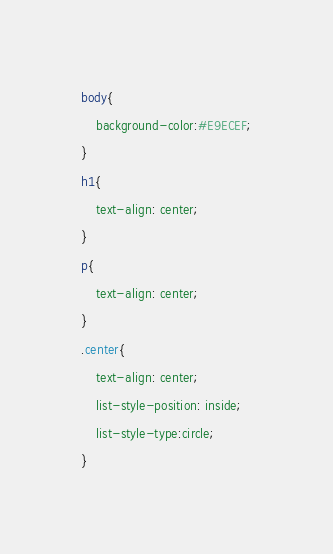Convert code to text. <code><loc_0><loc_0><loc_500><loc_500><_CSS_>body{
    background-color:#E9ECEF;
}
h1{
    text-align: center;
}
p{
    text-align: center;
}
.center{
    text-align: center;
    list-style-position: inside;
    list-style-type:circle;
}



</code> 